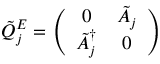Convert formula to latex. <formula><loc_0><loc_0><loc_500><loc_500>\tilde { Q } _ { j } ^ { E } = \left ( \begin{array} { c c } { 0 } & { { \tilde { A } _ { j } } } \\ { { \tilde { A } _ { j } ^ { \dagger } } } & { 0 } \end{array} \right )</formula> 